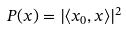Convert formula to latex. <formula><loc_0><loc_0><loc_500><loc_500>P ( x ) = | \langle x _ { 0 } , x \rangle | ^ { 2 }</formula> 